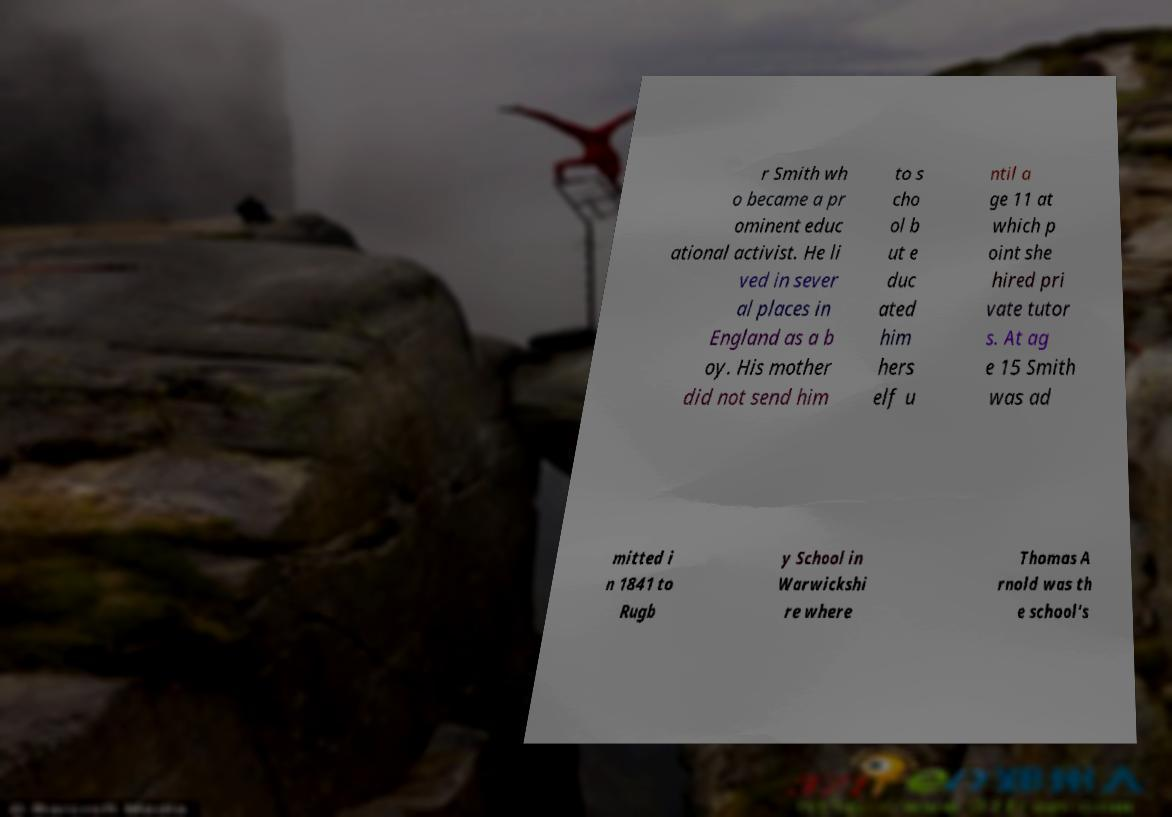Could you assist in decoding the text presented in this image and type it out clearly? r Smith wh o became a pr ominent educ ational activist. He li ved in sever al places in England as a b oy. His mother did not send him to s cho ol b ut e duc ated him hers elf u ntil a ge 11 at which p oint she hired pri vate tutor s. At ag e 15 Smith was ad mitted i n 1841 to Rugb y School in Warwickshi re where Thomas A rnold was th e school's 